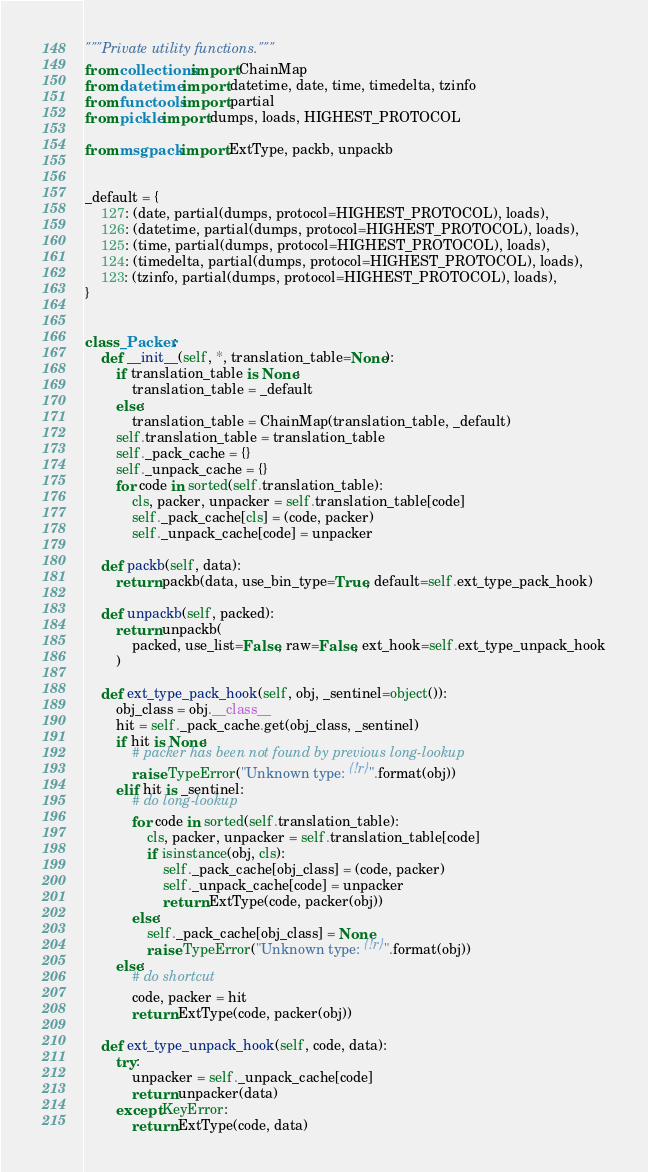<code> <loc_0><loc_0><loc_500><loc_500><_Python_>"""Private utility functions."""
from collections import ChainMap
from datetime import datetime, date, time, timedelta, tzinfo
from functools import partial
from pickle import dumps, loads, HIGHEST_PROTOCOL

from msgpack import ExtType, packb, unpackb


_default = {
    127: (date, partial(dumps, protocol=HIGHEST_PROTOCOL), loads),
    126: (datetime, partial(dumps, protocol=HIGHEST_PROTOCOL), loads),
    125: (time, partial(dumps, protocol=HIGHEST_PROTOCOL), loads),
    124: (timedelta, partial(dumps, protocol=HIGHEST_PROTOCOL), loads),
    123: (tzinfo, partial(dumps, protocol=HIGHEST_PROTOCOL), loads),
}


class _Packer:
    def __init__(self, *, translation_table=None):
        if translation_table is None:
            translation_table = _default
        else:
            translation_table = ChainMap(translation_table, _default)
        self.translation_table = translation_table
        self._pack_cache = {}
        self._unpack_cache = {}
        for code in sorted(self.translation_table):
            cls, packer, unpacker = self.translation_table[code]
            self._pack_cache[cls] = (code, packer)
            self._unpack_cache[code] = unpacker

    def packb(self, data):
        return packb(data, use_bin_type=True, default=self.ext_type_pack_hook)

    def unpackb(self, packed):
        return unpackb(
            packed, use_list=False, raw=False, ext_hook=self.ext_type_unpack_hook
        )

    def ext_type_pack_hook(self, obj, _sentinel=object()):
        obj_class = obj.__class__
        hit = self._pack_cache.get(obj_class, _sentinel)
        if hit is None:
            # packer has been not found by previous long-lookup
            raise TypeError("Unknown type: {!r}".format(obj))
        elif hit is _sentinel:
            # do long-lookup
            for code in sorted(self.translation_table):
                cls, packer, unpacker = self.translation_table[code]
                if isinstance(obj, cls):
                    self._pack_cache[obj_class] = (code, packer)
                    self._unpack_cache[code] = unpacker
                    return ExtType(code, packer(obj))
            else:
                self._pack_cache[obj_class] = None
                raise TypeError("Unknown type: {!r}".format(obj))
        else:
            # do shortcut
            code, packer = hit
            return ExtType(code, packer(obj))

    def ext_type_unpack_hook(self, code, data):
        try:
            unpacker = self._unpack_cache[code]
            return unpacker(data)
        except KeyError:
            return ExtType(code, data)
</code> 